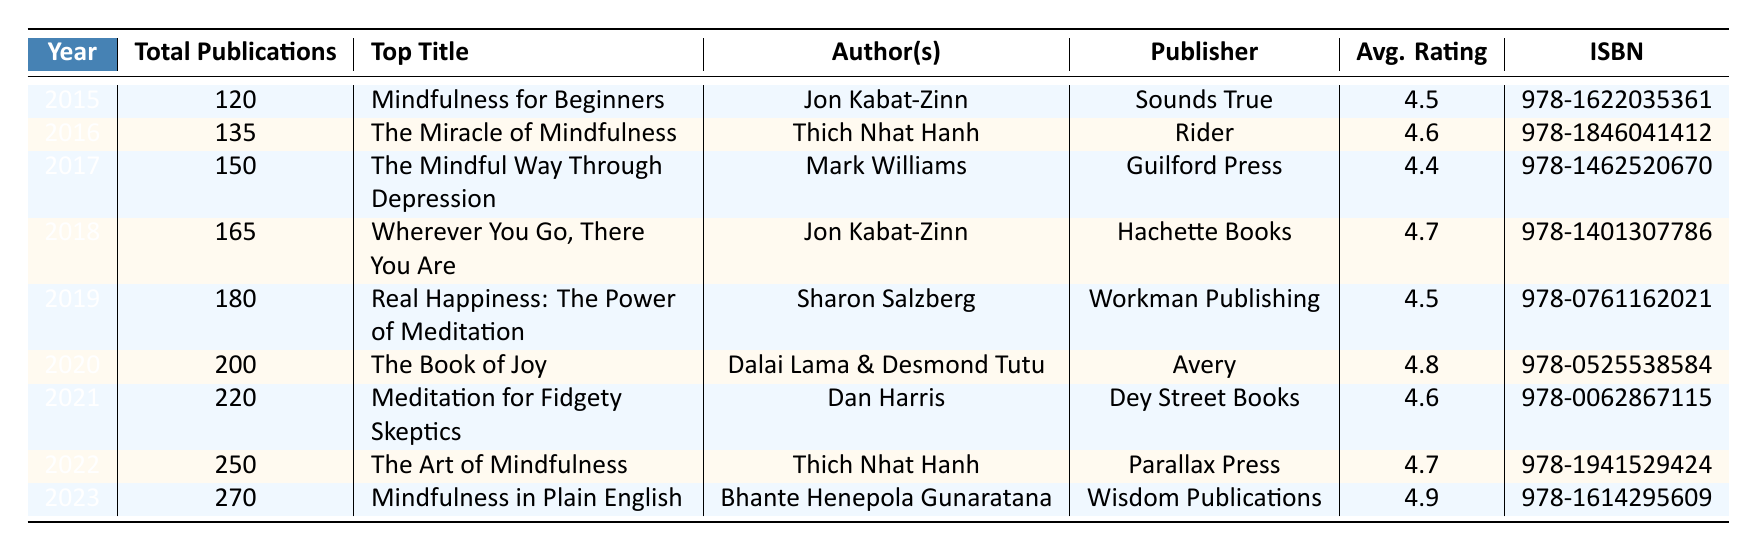What was the total number of mindfulness and meditation books published in 2019? Referring to the table, the entry for the year 2019 indicates "Total Publications" as 180.
Answer: 180 Who is the author of the top title for 2020? The table lists "The Book of Joy" as the top title published in 2020, authored by "Dalai Lama & Desmond Tutu."
Answer: Dalai Lama & Desmond Tutu How many total publications were there in 2021 compared to 2015? The table shows 220 publications for 2021 and 120 for 2015. The difference is calculated as 220 - 120 = 100.
Answer: 100 What is the average rating of the top titles from 2016 and 2017? The average rating for 2016 is 4.6 and for 2017 is 4.4. The sum is 4.6 + 4.4 = 9, divided by 2 gives 9/2 = 4.5.
Answer: 4.5 Which year had the highest number of total publications? By examining the table, it's clear that 2023 had the highest total publications at 270.
Answer: 2023 Did the total number of publications increase every year from 2015 to 2023? The table shows an increasing trend in total publications each year from 2015 (120) to 2023 (270), indicating continuous growth without any decrease.
Answer: Yes What is the difference in total publications between the years 2022 and 2020? According to the table, total publications for 2022 is 250 and for 2020 is 200. The difference is 250 - 200 = 50.
Answer: 50 Which publisher released the top title in 2023? The table specifies that "Mindfulness in Plain English," the top title for 2023, was published by Wisdom Publications.
Answer: Wisdom Publications What was the average number of publications per year from 2015 to 2023? Total publications from 2015 to 2023 are: 120 + 135 + 150 + 165 + 180 + 200 + 220 + 250 + 270 = 1570. There are 9 years, so the average is 1570/9 ≈ 174.44.
Answer: 174.44 In which year was the top-rated book published? The table shows that the top-rated book in 2023, "Mindfulness in Plain English," has the highest average rating of 4.9, indicating that 2023 is the year of its publication.
Answer: 2023 